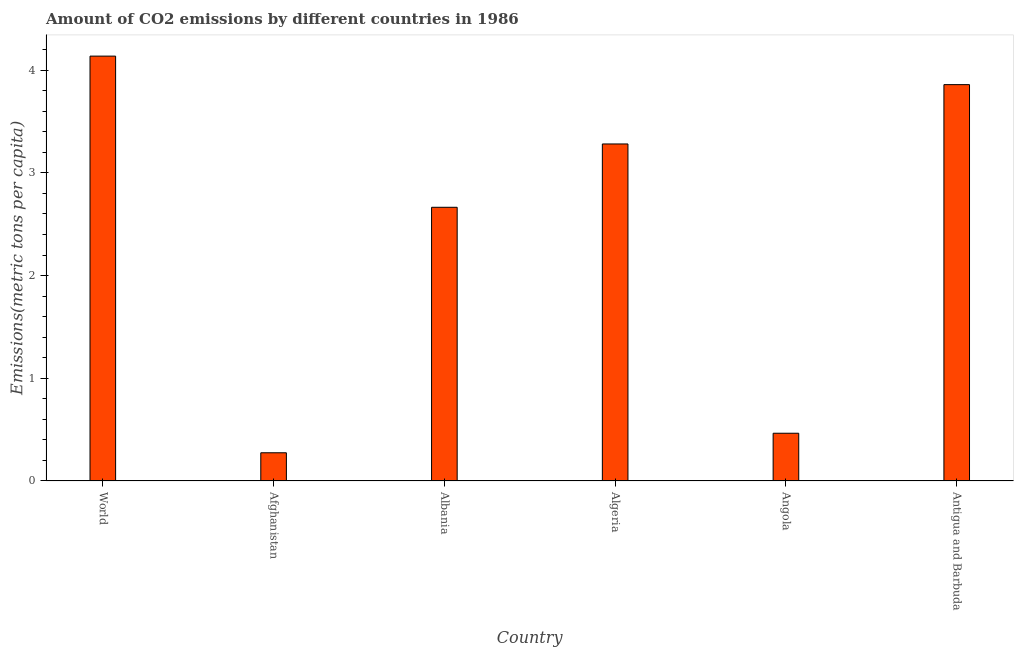What is the title of the graph?
Your answer should be compact. Amount of CO2 emissions by different countries in 1986. What is the label or title of the Y-axis?
Your response must be concise. Emissions(metric tons per capita). What is the amount of co2 emissions in Antigua and Barbuda?
Give a very brief answer. 3.86. Across all countries, what is the maximum amount of co2 emissions?
Make the answer very short. 4.14. Across all countries, what is the minimum amount of co2 emissions?
Keep it short and to the point. 0.27. In which country was the amount of co2 emissions maximum?
Your answer should be very brief. World. In which country was the amount of co2 emissions minimum?
Your response must be concise. Afghanistan. What is the sum of the amount of co2 emissions?
Ensure brevity in your answer.  14.68. What is the difference between the amount of co2 emissions in Angola and Antigua and Barbuda?
Your answer should be very brief. -3.4. What is the average amount of co2 emissions per country?
Offer a very short reply. 2.45. What is the median amount of co2 emissions?
Make the answer very short. 2.97. What is the ratio of the amount of co2 emissions in Afghanistan to that in Antigua and Barbuda?
Your answer should be compact. 0.07. Is the amount of co2 emissions in Afghanistan less than that in World?
Your answer should be very brief. Yes. Is the difference between the amount of co2 emissions in Afghanistan and Antigua and Barbuda greater than the difference between any two countries?
Your answer should be compact. No. What is the difference between the highest and the second highest amount of co2 emissions?
Give a very brief answer. 0.28. Is the sum of the amount of co2 emissions in Albania and World greater than the maximum amount of co2 emissions across all countries?
Your answer should be very brief. Yes. What is the difference between the highest and the lowest amount of co2 emissions?
Your answer should be compact. 3.86. In how many countries, is the amount of co2 emissions greater than the average amount of co2 emissions taken over all countries?
Your answer should be very brief. 4. How many countries are there in the graph?
Ensure brevity in your answer.  6. What is the Emissions(metric tons per capita) of World?
Give a very brief answer. 4.14. What is the Emissions(metric tons per capita) in Afghanistan?
Offer a terse response. 0.27. What is the Emissions(metric tons per capita) of Albania?
Your answer should be very brief. 2.67. What is the Emissions(metric tons per capita) of Algeria?
Your response must be concise. 3.28. What is the Emissions(metric tons per capita) of Angola?
Your answer should be very brief. 0.46. What is the Emissions(metric tons per capita) in Antigua and Barbuda?
Offer a very short reply. 3.86. What is the difference between the Emissions(metric tons per capita) in World and Afghanistan?
Provide a succinct answer. 3.86. What is the difference between the Emissions(metric tons per capita) in World and Albania?
Ensure brevity in your answer.  1.47. What is the difference between the Emissions(metric tons per capita) in World and Algeria?
Make the answer very short. 0.86. What is the difference between the Emissions(metric tons per capita) in World and Angola?
Offer a terse response. 3.67. What is the difference between the Emissions(metric tons per capita) in World and Antigua and Barbuda?
Provide a short and direct response. 0.28. What is the difference between the Emissions(metric tons per capita) in Afghanistan and Albania?
Offer a terse response. -2.39. What is the difference between the Emissions(metric tons per capita) in Afghanistan and Algeria?
Keep it short and to the point. -3.01. What is the difference between the Emissions(metric tons per capita) in Afghanistan and Angola?
Make the answer very short. -0.19. What is the difference between the Emissions(metric tons per capita) in Afghanistan and Antigua and Barbuda?
Ensure brevity in your answer.  -3.58. What is the difference between the Emissions(metric tons per capita) in Albania and Algeria?
Your answer should be compact. -0.62. What is the difference between the Emissions(metric tons per capita) in Albania and Angola?
Make the answer very short. 2.2. What is the difference between the Emissions(metric tons per capita) in Albania and Antigua and Barbuda?
Provide a succinct answer. -1.19. What is the difference between the Emissions(metric tons per capita) in Algeria and Angola?
Give a very brief answer. 2.82. What is the difference between the Emissions(metric tons per capita) in Algeria and Antigua and Barbuda?
Provide a succinct answer. -0.58. What is the difference between the Emissions(metric tons per capita) in Angola and Antigua and Barbuda?
Keep it short and to the point. -3.39. What is the ratio of the Emissions(metric tons per capita) in World to that in Afghanistan?
Ensure brevity in your answer.  15.06. What is the ratio of the Emissions(metric tons per capita) in World to that in Albania?
Give a very brief answer. 1.55. What is the ratio of the Emissions(metric tons per capita) in World to that in Algeria?
Your answer should be very brief. 1.26. What is the ratio of the Emissions(metric tons per capita) in World to that in Angola?
Ensure brevity in your answer.  8.9. What is the ratio of the Emissions(metric tons per capita) in World to that in Antigua and Barbuda?
Your answer should be very brief. 1.07. What is the ratio of the Emissions(metric tons per capita) in Afghanistan to that in Albania?
Give a very brief answer. 0.1. What is the ratio of the Emissions(metric tons per capita) in Afghanistan to that in Algeria?
Offer a very short reply. 0.08. What is the ratio of the Emissions(metric tons per capita) in Afghanistan to that in Angola?
Your answer should be compact. 0.59. What is the ratio of the Emissions(metric tons per capita) in Afghanistan to that in Antigua and Barbuda?
Your response must be concise. 0.07. What is the ratio of the Emissions(metric tons per capita) in Albania to that in Algeria?
Offer a very short reply. 0.81. What is the ratio of the Emissions(metric tons per capita) in Albania to that in Angola?
Your response must be concise. 5.73. What is the ratio of the Emissions(metric tons per capita) in Albania to that in Antigua and Barbuda?
Give a very brief answer. 0.69. What is the ratio of the Emissions(metric tons per capita) in Algeria to that in Angola?
Your answer should be compact. 7.06. What is the ratio of the Emissions(metric tons per capita) in Angola to that in Antigua and Barbuda?
Provide a succinct answer. 0.12. 